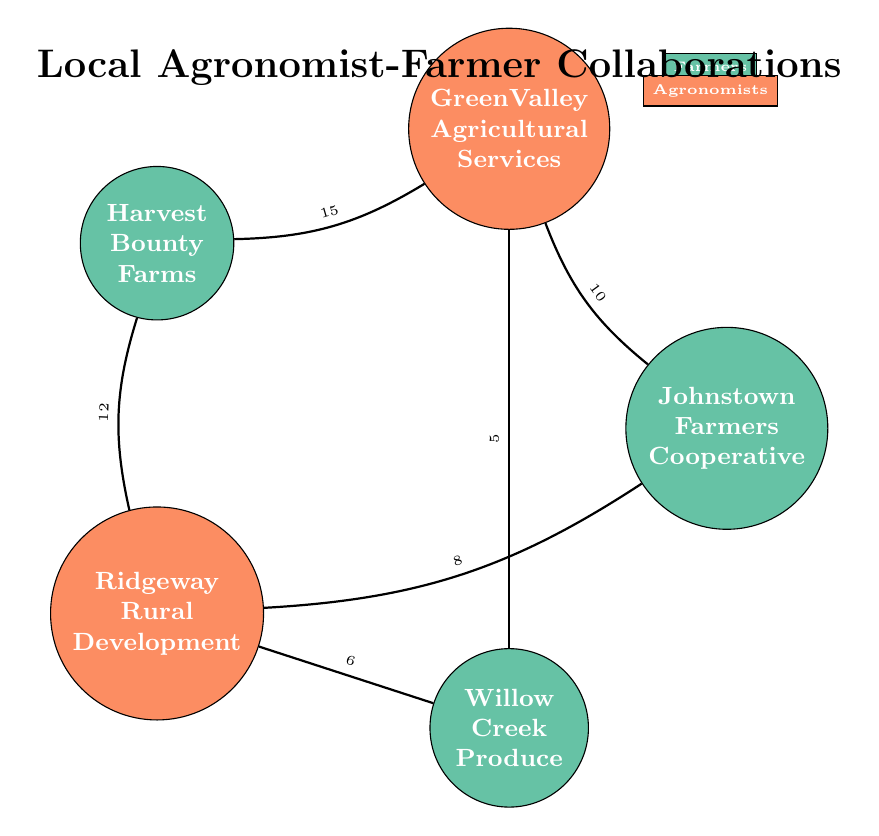What is the total number of farmers represented in the diagram? The diagram contains three nodes categorized as farmers: Johnstown Farmers Cooperative, Harvest Bounty Farms, and Willow Creek Produce. Counting these nodes gives a total of 3 farmers.
Answer: 3 Which agronomist has the strongest collaboration with Harvest Bounty Farms? Harvest Bounty Farms connects to two agronomists: GreenValley Agricultural Services with a value of 15 and Ridgeway Rural Development with a value of 12. The highest value is 15, indicating that GreenValley Agricultural Services has the strongest collaboration.
Answer: GreenValley Agricultural Services What is the value of the collaboration between Willow Creek Produce and Ridgeway Rural Development? The link between Willow Creek Produce and Ridgeway Rural Development is shown in the diagram with a value of 6. This value directly represents the strength of their collaboration.
Answer: 6 How many total collaborations are indicated in the diagram? The diagram shows 6 links connecting different farmers and agronomists. Each link is a collaboration and contributes to the total count, resulting in 6 collaborations in total.
Answer: 6 Which farmer has collaborated with GreenValley Agricultural Services? The diagram shows three connections to GreenValley Agricultural Services: Johnstown Farmers Cooperative (10), Harvest Bounty Farms (15), and Willow Creek Produce (5). Therefore, Johnstown Farmers Cooperative, Harvest Bounty Farms, and Willow Creek Produce are the farmers that collaborated with this agronomist.
Answer: Johnstown Farmers Cooperative, Harvest Bounty Farms, Willow Creek Produce Which collaboration has the highest value among all shown in the diagram? The connections with the highest values are identified by reviewing the link values: 10, 15, 5, 8, 12, and 6. The highest value is 15, which corresponds to the collaboration between Harvest Bounty Farms and GreenValley Agricultural Services.
Answer: 15 